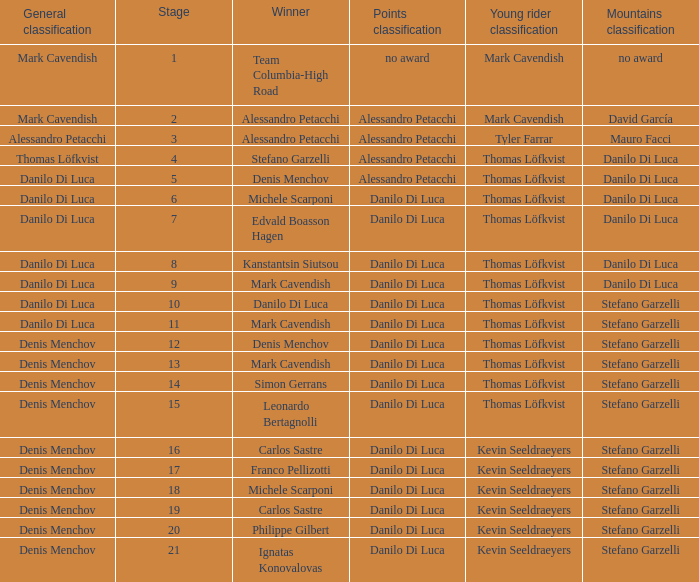When 19 is the stage who is the points classification? Danilo Di Luca. 